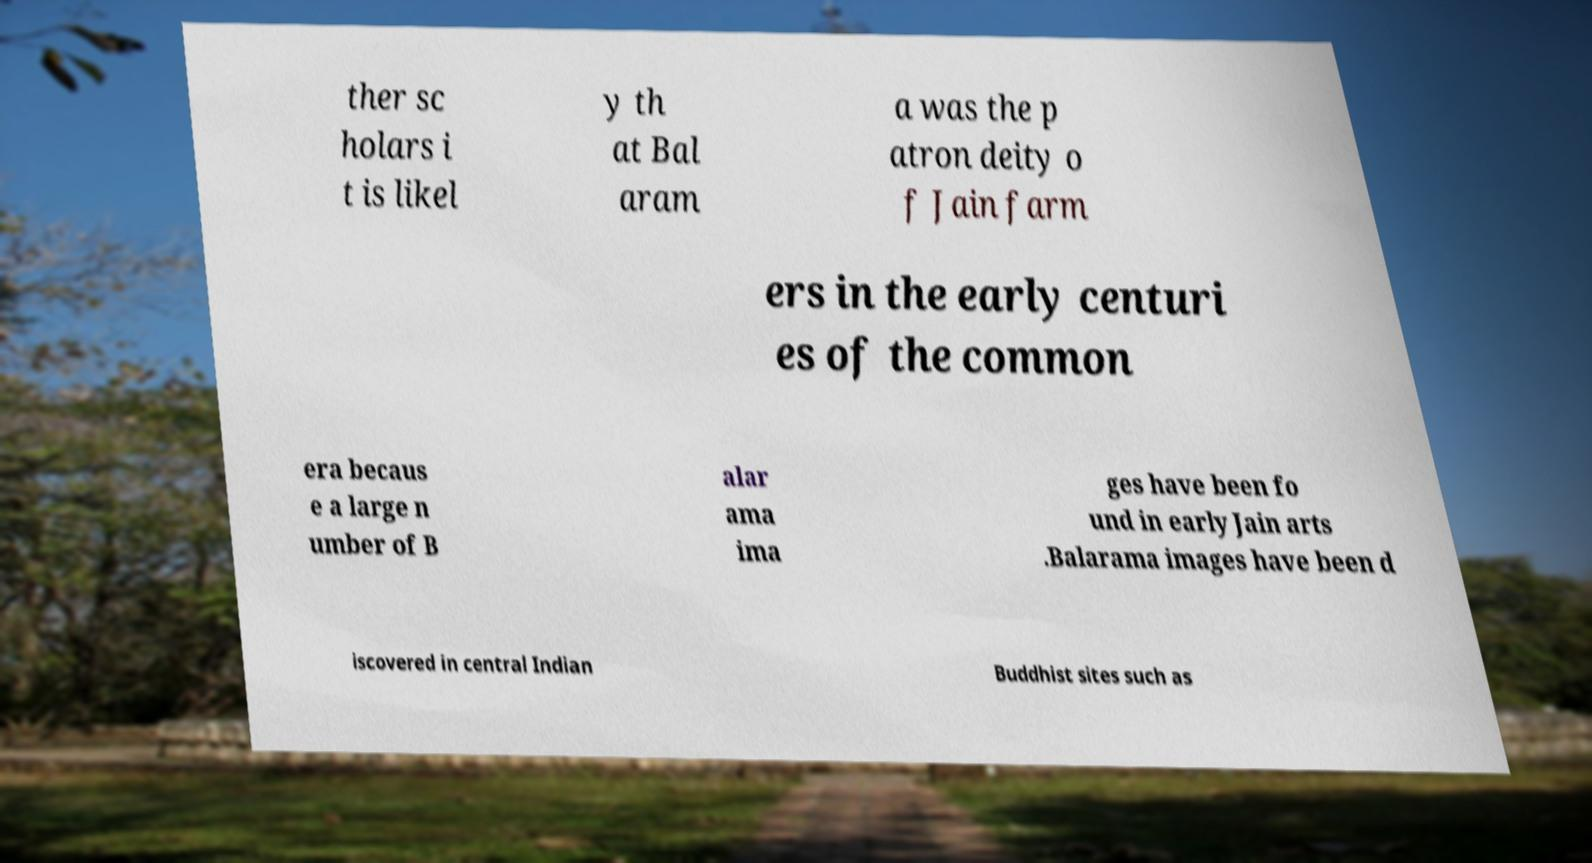I need the written content from this picture converted into text. Can you do that? ther sc holars i t is likel y th at Bal aram a was the p atron deity o f Jain farm ers in the early centuri es of the common era becaus e a large n umber of B alar ama ima ges have been fo und in early Jain arts .Balarama images have been d iscovered in central Indian Buddhist sites such as 